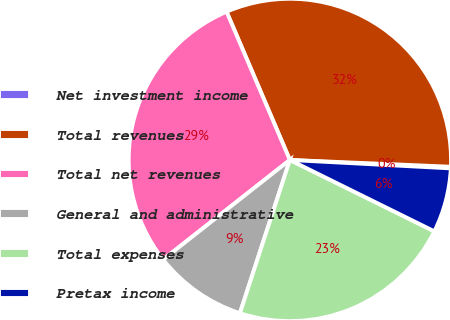Convert chart. <chart><loc_0><loc_0><loc_500><loc_500><pie_chart><fcel>Net investment income<fcel>Total revenues<fcel>Total net revenues<fcel>General and administrative<fcel>Total expenses<fcel>Pretax income<nl><fcel>0.16%<fcel>32.09%<fcel>29.18%<fcel>9.38%<fcel>22.71%<fcel>6.47%<nl></chart> 